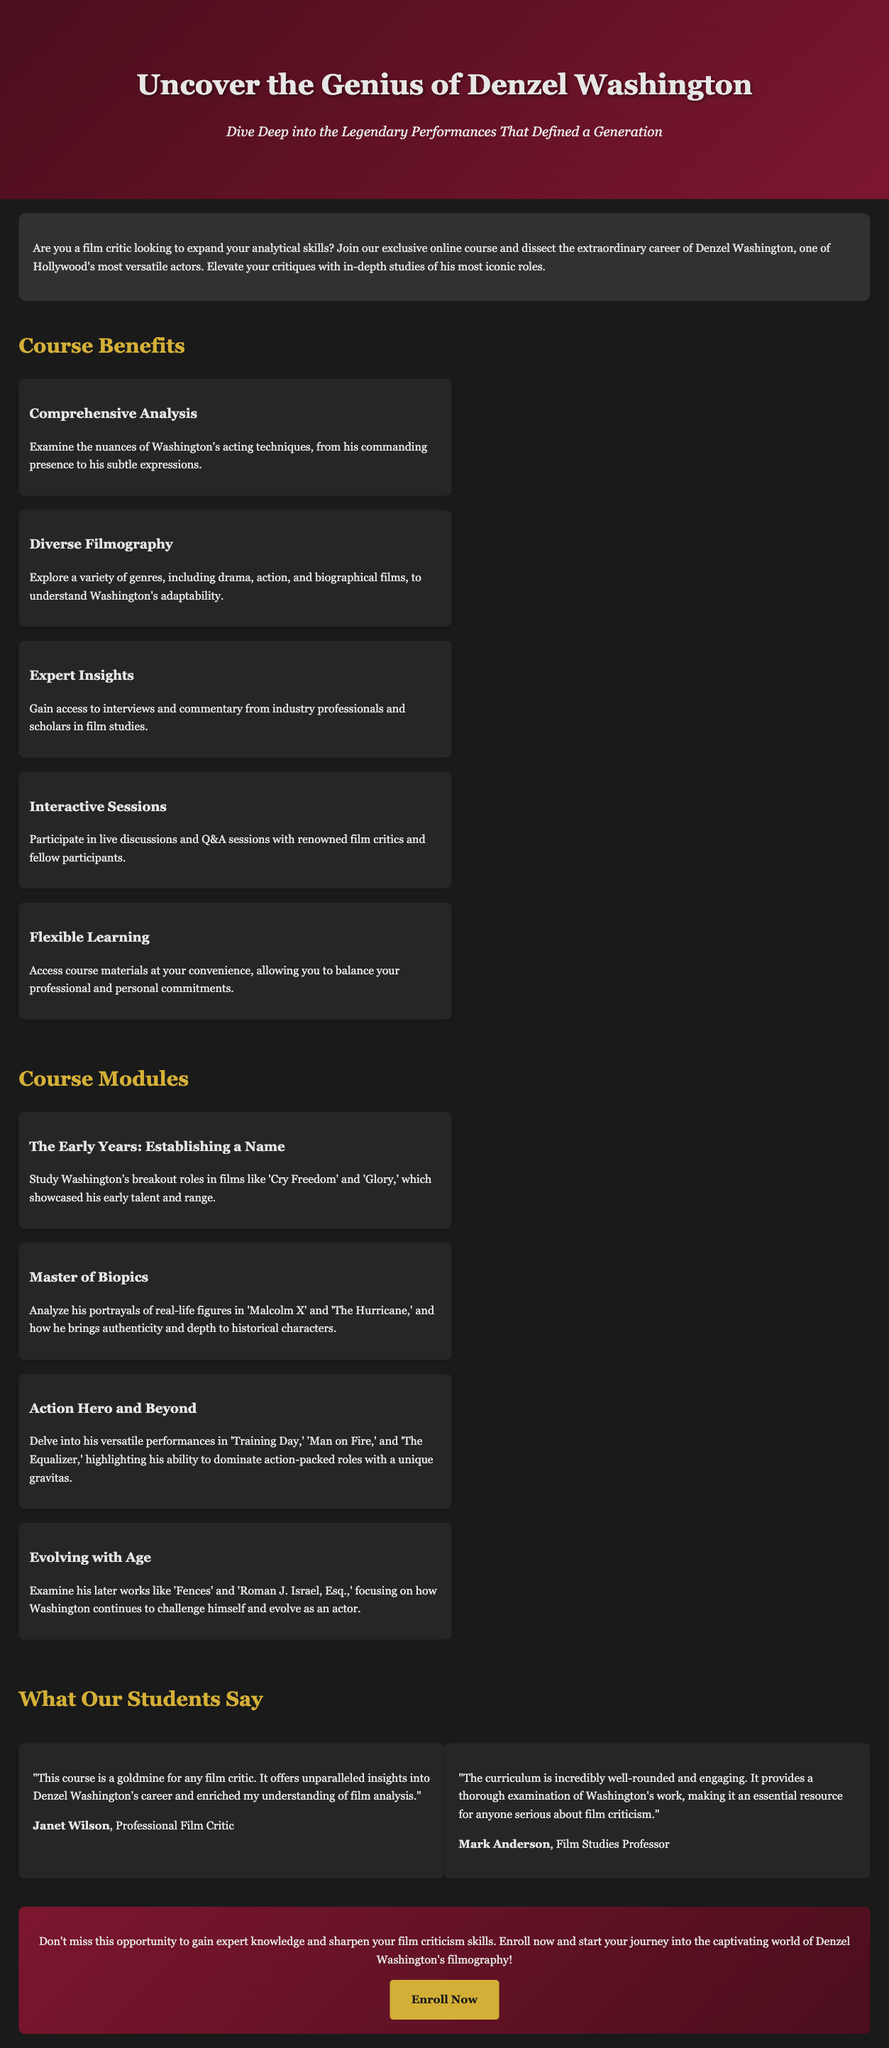What is the course title? The title of the course is mentioned prominently in the document header.
Answer: Denzel Washington Film Criticism Course Who is the course designed for? The introduction states that the course is aimed at film critics looking to enhance their skills.
Answer: Film critic What is one of the course benefits? The benefits section lists several aspects, and the first item highlights a specific advantage.
Answer: Comprehensive Analysis Name a module covered in the course. The document lists several modules under the course modules section, each focusing on a different aspect of Washington's career.
Answer: The Early Years: Establishing a Name Who provided a testimonial about the course? The testimonials section mentions two individuals who commented on the course's value.
Answer: Janet Wilson What type of learning does the course offer? The benefits section includes a specific aspect that highlights the flexibility of course participation.
Answer: Flexible Learning How many modules are listed in the document? By counting the individual items under the course modules section, one can determine the number of modules.
Answer: Four What phrase is used to encourage enrollment? In the call-to-action section, a specific phrase incites readers to take action and enroll.
Answer: Enroll Now What genre of films does the course explore? The benefits section discusses a variety of genres covered in the course, noting Washington's adaptability.
Answer: Diverse Filmography 